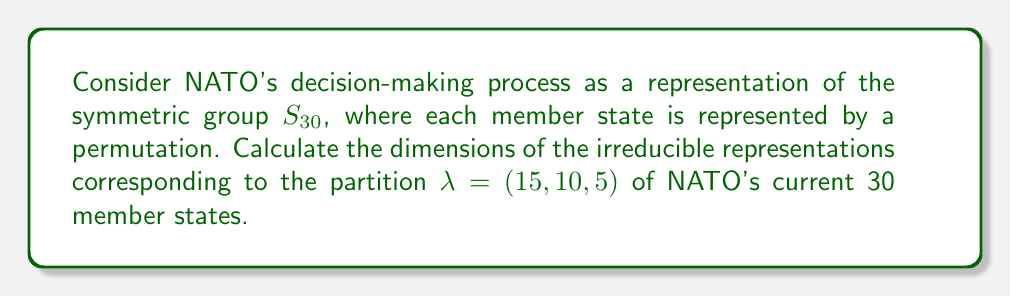Could you help me with this problem? To calculate the dimensions of irreducible representations for the symmetric group $S_n$, we use the hook length formula. For a partition $\lambda$ of $n$, the dimension $d_\lambda$ is given by:

$$d_\lambda = \frac{n!}{\prod_{(i,j) \in \lambda} h_{ij}}$$

where $h_{ij}$ is the hook length of the cell $(i,j)$ in the Young diagram of $\lambda$.

For $\lambda = (15, 10, 5)$:

1. Construct the Young diagram:
   [asy]
   unitsize(0.5cm);
   for(int i=0; i<15; ++i) draw((0,0)--(15,0));
   for(int i=0; i<10; ++i) draw((0,-1)--(10,-1));
   for(int i=0; i<5; ++i) draw((0,-2)--(5,-2));
   for(int j=0; j<3; ++j) draw((0,-j)--(0,0));
   for(int j=1; j<5; ++j) draw((j,-2)--(j,0));
   for(int j=5; j<10; ++j) draw((j,-1)--(j,0));
   for(int j=10; j<15; ++j) draw((j,0)--(j,1));
   [/asy]

2. Calculate hook lengths:
   - First row: 17, 16, 15, 14, 13, 12, 11, 10, 9, 8, 7, 6, 5, 4, 3
   - Second row: 11, 10, 9, 8, 7, 6, 5, 4, 3, 2
   - Third row: 5, 4, 3, 2, 1

3. Apply the hook length formula:

   $$d_\lambda = \frac{30!}{(17 \cdot 16 \cdot 15 \cdot 14 \cdot 13 \cdot 12 \cdot 11 \cdot 10 \cdot 9 \cdot 8 \cdot 7 \cdot 6 \cdot 5 \cdot 4 \cdot 3) \cdot (11 \cdot 10 \cdot 9 \cdot 8 \cdot 7 \cdot 6 \cdot 5 \cdot 4 \cdot 3 \cdot 2) \cdot (5 \cdot 4 \cdot 3 \cdot 2 \cdot 1)}$$

4. Simplify and calculate:

   $$d_\lambda = \frac{30!}{17 \cdot 16 \cdot 15 \cdot 14 \cdot 13 \cdot 12 \cdot 11^2 \cdot 10^2 \cdot 9^2 \cdot 8^2 \cdot 7^2 \cdot 6^2 \cdot 5^3 \cdot 4^3 \cdot 3^3 \cdot 2^2 \cdot 1} = 11,998,396,800$$
Answer: $11,998,396,800$ 